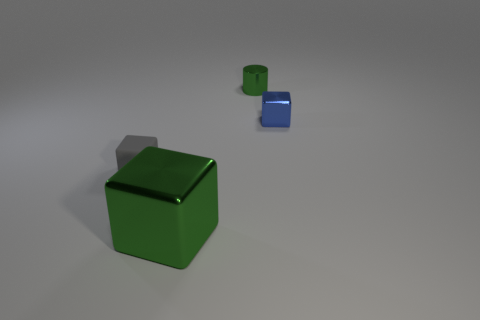Subtract all shiny blocks. How many blocks are left? 1 Add 1 small gray objects. How many objects exist? 5 Subtract all green cubes. How many cubes are left? 2 Subtract all cylinders. How many objects are left? 3 Subtract 1 cylinders. How many cylinders are left? 0 Subtract all yellow cubes. Subtract all cyan balls. How many cubes are left? 3 Subtract all purple spheres. How many green cubes are left? 1 Subtract all tiny brown spheres. Subtract all small metal cylinders. How many objects are left? 3 Add 2 tiny blue cubes. How many tiny blue cubes are left? 3 Add 2 small spheres. How many small spheres exist? 2 